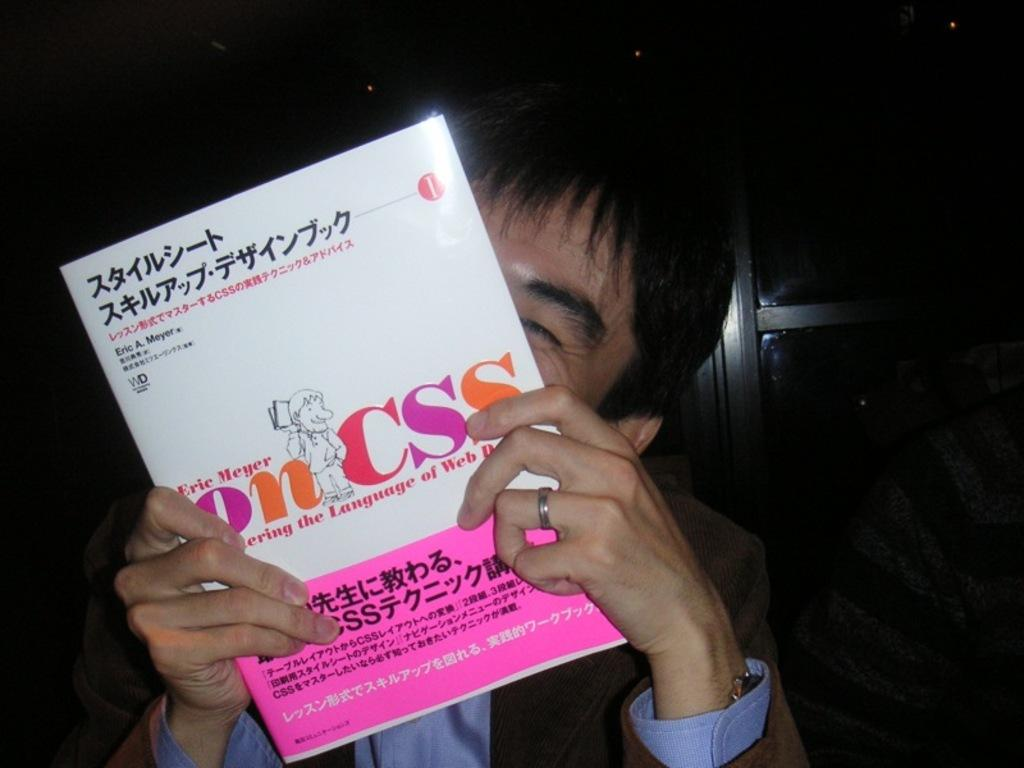Who is present in the image? There is a man in the image. What is the man holding in his hand? The man is holding a book in his hand. Can you describe the appearance of the book? The book is white and pink in color. What type of hat is the man wearing in the image? There is no hat present in the image; the man is holding a book. 